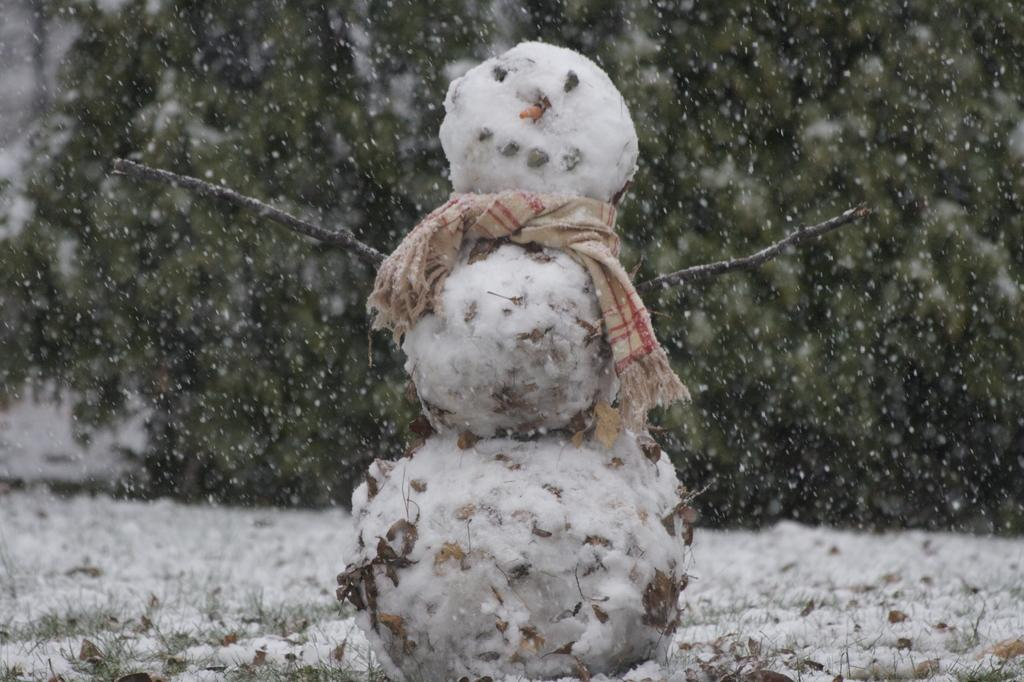What is the main subject in the foreground of the image? There is a snowman in the foreground of the image. What can be seen in the background of the image? There is a tree in the background of the image. What type of weather condition is depicted in the image? There is snow visible at the bottom of the image, indicating a snowy environment. What type of skin is visible on the snowman in the image? The snowman is made of snow and does not have skin. How does the butter contribute to the image? There is no butter present in the image. 